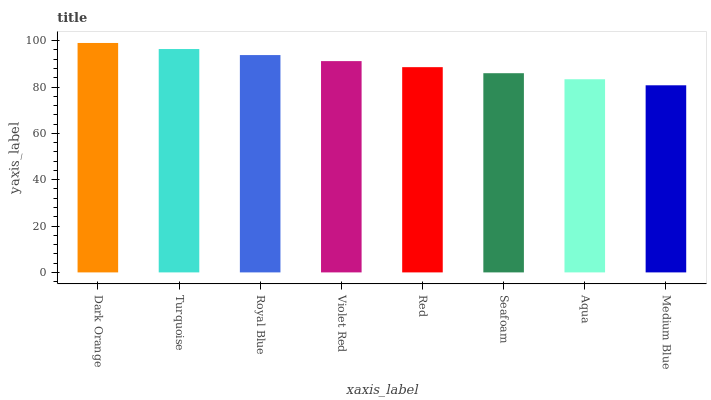Is Medium Blue the minimum?
Answer yes or no. Yes. Is Dark Orange the maximum?
Answer yes or no. Yes. Is Turquoise the minimum?
Answer yes or no. No. Is Turquoise the maximum?
Answer yes or no. No. Is Dark Orange greater than Turquoise?
Answer yes or no. Yes. Is Turquoise less than Dark Orange?
Answer yes or no. Yes. Is Turquoise greater than Dark Orange?
Answer yes or no. No. Is Dark Orange less than Turquoise?
Answer yes or no. No. Is Violet Red the high median?
Answer yes or no. Yes. Is Red the low median?
Answer yes or no. Yes. Is Turquoise the high median?
Answer yes or no. No. Is Violet Red the low median?
Answer yes or no. No. 